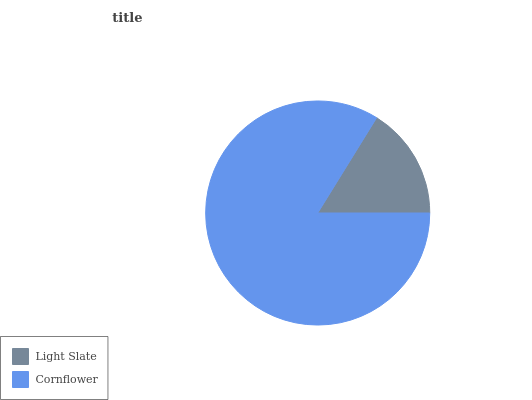Is Light Slate the minimum?
Answer yes or no. Yes. Is Cornflower the maximum?
Answer yes or no. Yes. Is Cornflower the minimum?
Answer yes or no. No. Is Cornflower greater than Light Slate?
Answer yes or no. Yes. Is Light Slate less than Cornflower?
Answer yes or no. Yes. Is Light Slate greater than Cornflower?
Answer yes or no. No. Is Cornflower less than Light Slate?
Answer yes or no. No. Is Cornflower the high median?
Answer yes or no. Yes. Is Light Slate the low median?
Answer yes or no. Yes. Is Light Slate the high median?
Answer yes or no. No. Is Cornflower the low median?
Answer yes or no. No. 